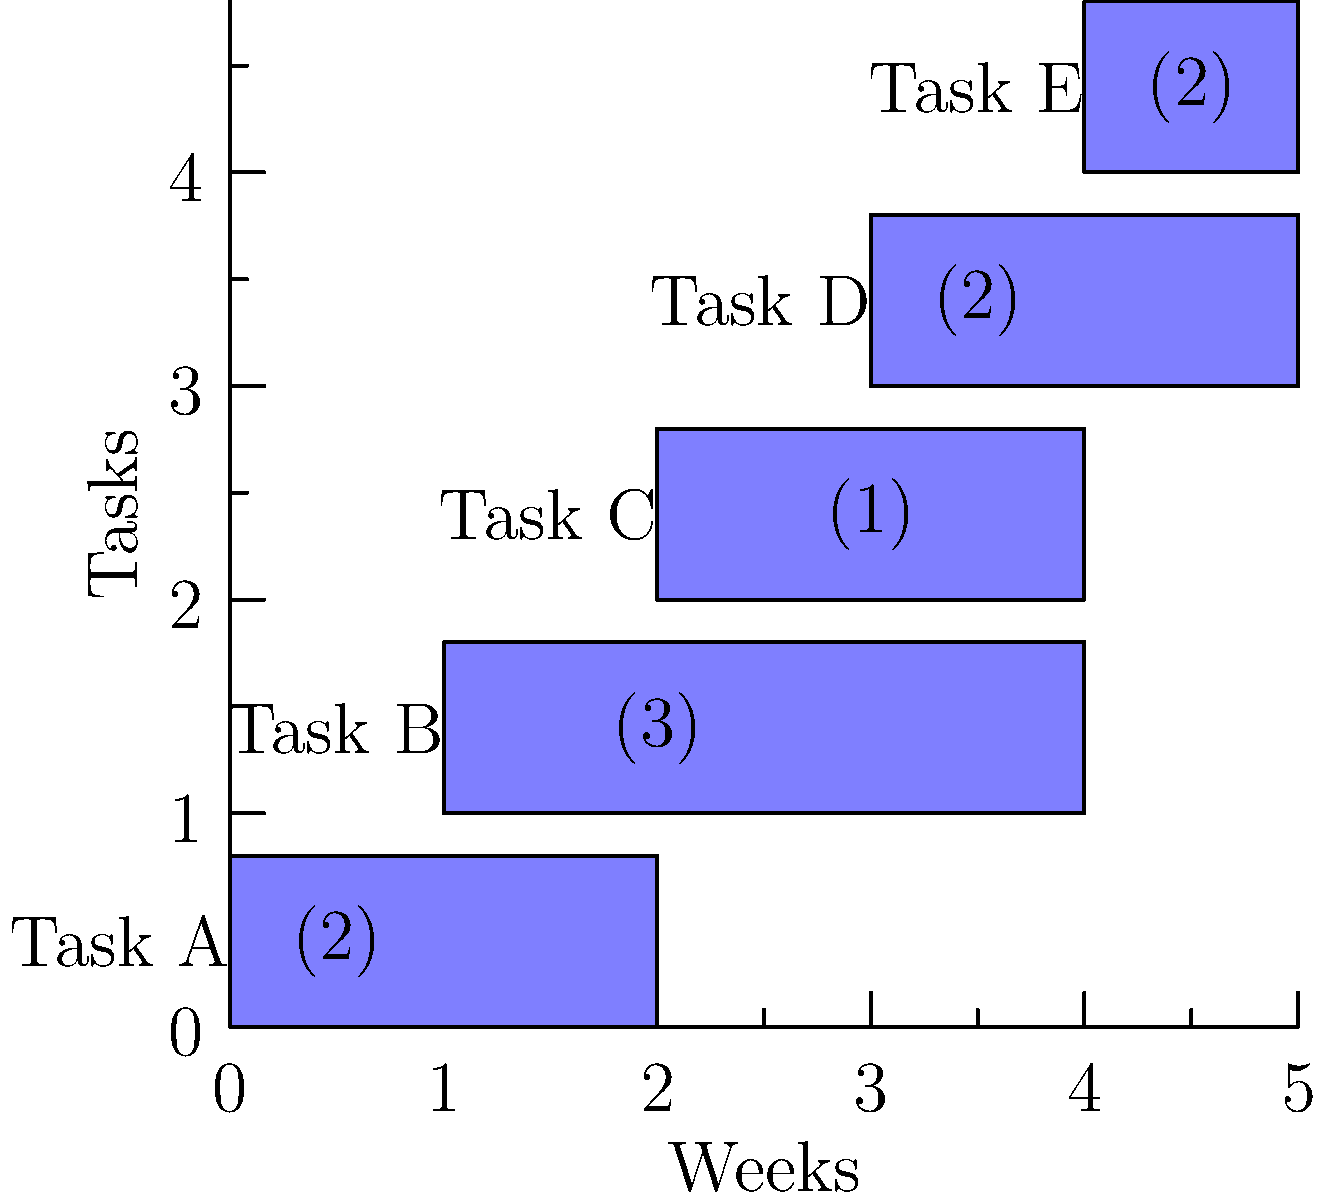As a project manager, you're analyzing the Gantt chart above for a new product development project. The numbers in parentheses represent the number of team members allocated to each task. What is the maximum number of team members working simultaneously at any point during the project, and in which week does this peak occur? To answer this question, we need to analyze the resource allocation throughout the project timeline:

1. Examine each week and sum up the resources allocated to concurrent tasks:

   Week 1: Task A (2 members)
   Total: 2 members

   Week 2: Task A (2 members) + Task B (3 members)
   Total: 5 members

   Week 3: Task B (3 members) + Task C (1 member)
   Total: 4 members

   Week 4: Task C (1 member) + Task D (2 members)
   Total: 3 members

   Week 5: Task D (2 members) + Task E (2 members)
   Total: 4 members

2. Identify the maximum number of team members working simultaneously:
   The peak occurs in Week 2 with 5 team members.

3. Verify that this is indeed the highest point of resource allocation throughout the project timeline.

Therefore, the maximum number of team members working simultaneously is 5, and this peak occurs in Week 2.
Answer: 5 team members, Week 2 